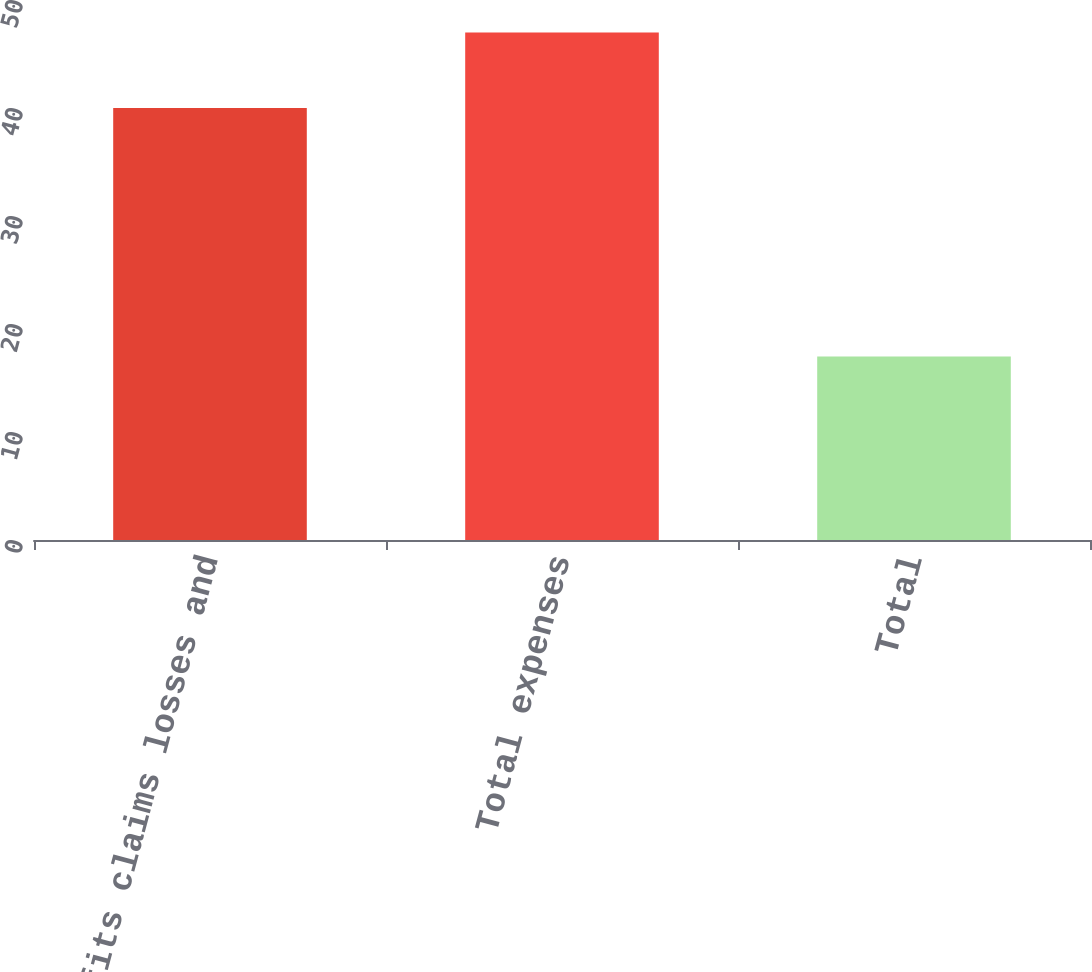Convert chart. <chart><loc_0><loc_0><loc_500><loc_500><bar_chart><fcel>Benefits claims losses and<fcel>Total expenses<fcel>Total<nl><fcel>40<fcel>47<fcel>17<nl></chart> 